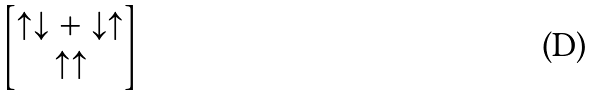Convert formula to latex. <formula><loc_0><loc_0><loc_500><loc_500>\begin{bmatrix} \uparrow \downarrow + \downarrow \uparrow \\ \uparrow \uparrow \end{bmatrix}</formula> 